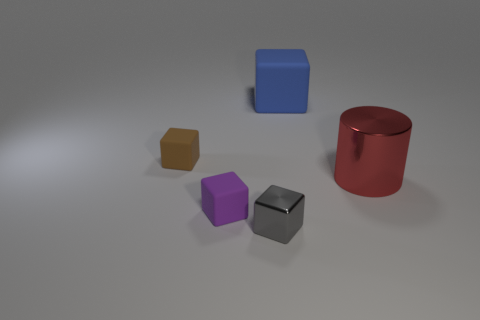What is the material of the cylinder?
Offer a very short reply. Metal. What is the block that is in front of the rubber cube that is in front of the cylinder made of?
Give a very brief answer. Metal. What number of other things are made of the same material as the gray thing?
Your answer should be compact. 1. What material is the gray cube that is in front of the purple rubber thing that is left of the cube that is behind the brown rubber cube made of?
Ensure brevity in your answer.  Metal. Is there any other thing that has the same shape as the tiny purple matte object?
Make the answer very short. Yes. Is the large block made of the same material as the big thing that is in front of the small brown matte thing?
Ensure brevity in your answer.  No. What is the color of the thing that is both to the right of the purple object and on the left side of the big blue rubber cube?
Make the answer very short. Gray. What number of spheres are tiny things or gray things?
Your answer should be very brief. 0. Does the gray object have the same shape as the small rubber object that is in front of the metallic cylinder?
Give a very brief answer. Yes. What size is the object that is behind the purple rubber block and in front of the small brown object?
Provide a succinct answer. Large. 